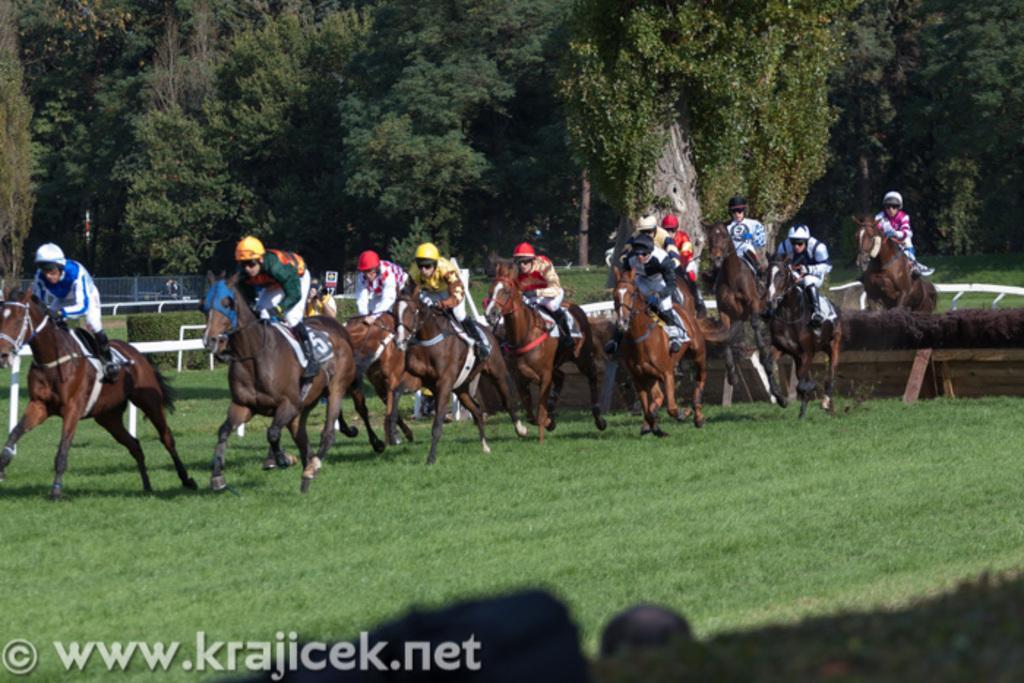How would you summarize this image in a sentence or two? This image is taken outdoors. At the bottom of the image there is a ground with grass on it. In the background there are many trees with leaves, stems and branches and there are a few plants. There are a few fences. In the middle of the image a few people are riding on the horses. 